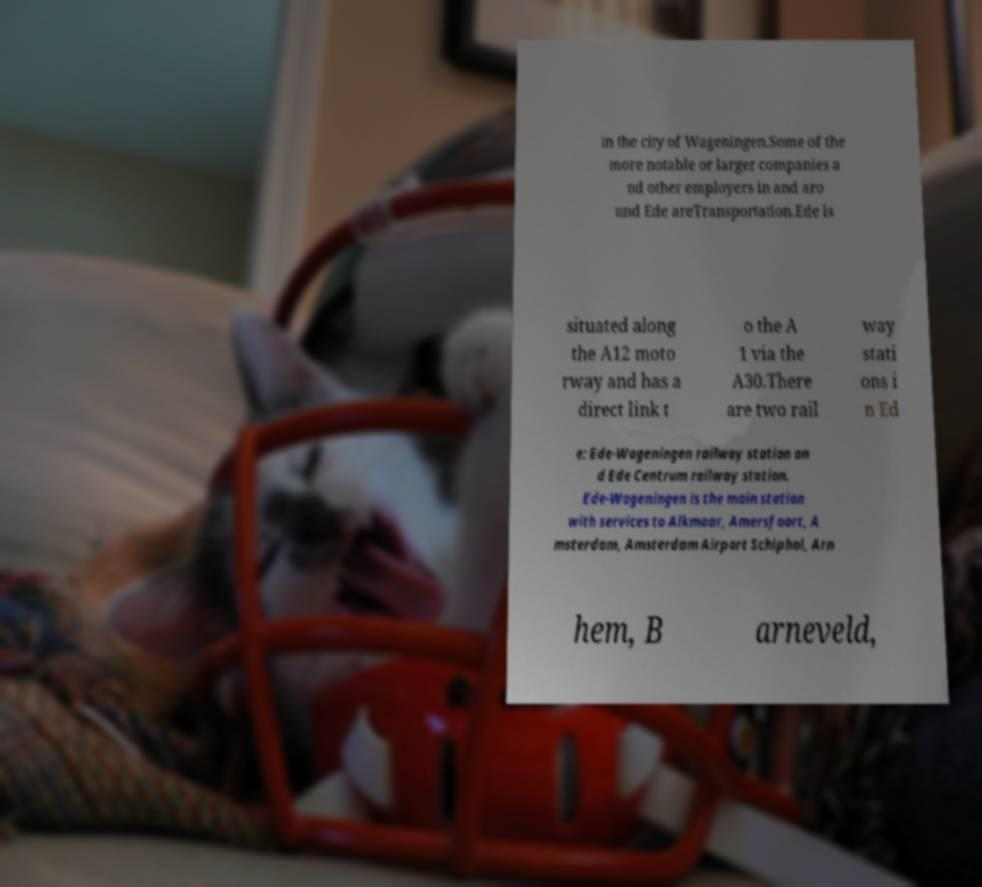There's text embedded in this image that I need extracted. Can you transcribe it verbatim? in the city of Wageningen.Some of the more notable or larger companies a nd other employers in and aro und Ede areTransportation.Ede is situated along the A12 moto rway and has a direct link t o the A 1 via the A30.There are two rail way stati ons i n Ed e: Ede-Wageningen railway station an d Ede Centrum railway station. Ede-Wageningen is the main station with services to Alkmaar, Amersfoort, A msterdam, Amsterdam Airport Schiphol, Arn hem, B arneveld, 